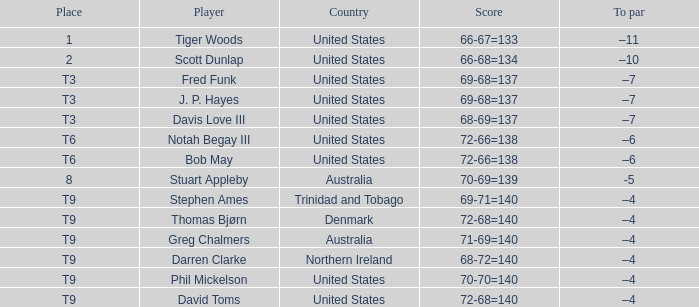Which location had a to par of -10? 2.0. 